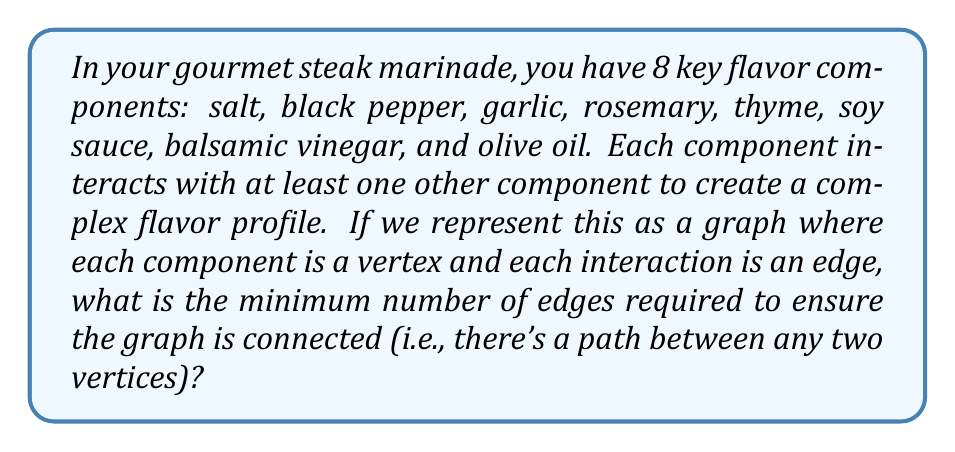Provide a solution to this math problem. To solve this problem, we need to apply the concept of a minimum spanning tree in graph theory.

1) First, recall that in a connected graph with $n$ vertices, a spanning tree is a subgraph that includes all vertices and is a tree (i.e., has no cycles).

2) A minimum spanning tree is a spanning tree with the minimum possible number of edges.

3) In this case, we have $n = 8$ vertices (flavor components).

4) A key property of trees is that the number of edges in a tree with $n$ vertices is always $n - 1$.

5) Therefore, the minimum number of edges required to connect all 8 vertices is:

   $$\text{Number of edges} = n - 1 = 8 - 1 = 7$$

6) This configuration ensures that all flavor components are connected in the network while using the minimum number of interactions.

7) It's worth noting that this minimum spanning tree doesn't represent all possible flavor interactions, but rather the minimal set of interactions needed to ensure all components are connected in the flavor network.

[asy]
unitsize(30);
pair[] v = {(0,0), (1,1), (2,0), (3,1), (4,0), (5,1), (6,0), (7,1)};
for(int i = 0; i < 7; ++i) {
  draw(v[i]--v[i+1]);
}
for(int i = 0; i < 8; ++i) {
  dot(v[i]);
}
label("Salt", v[0], S);
label("Pepper", v[1], N);
label("Garlic", v[2], S);
label("Rosemary", v[3], N);
label("Thyme", v[4], S);
label("Soy sauce", v[5], N);
label("Balsamic", v[6], S);
label("Olive oil", v[7], N);
[/asy]

This diagram illustrates one possible minimum spanning tree for the flavor network.
Answer: The minimum number of edges required to ensure the graph is connected is 7. 